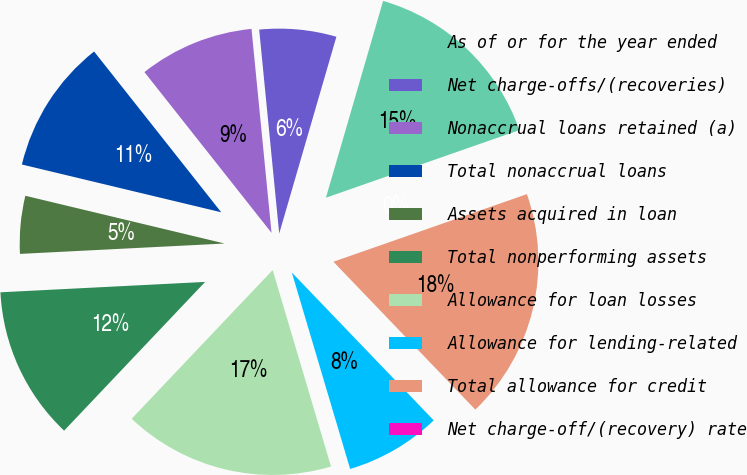Convert chart. <chart><loc_0><loc_0><loc_500><loc_500><pie_chart><fcel>As of or for the year ended<fcel>Net charge-offs/(recoveries)<fcel>Nonaccrual loans retained (a)<fcel>Total nonaccrual loans<fcel>Assets acquired in loan<fcel>Total nonperforming assets<fcel>Allowance for loan losses<fcel>Allowance for lending-related<fcel>Total allowance for credit<fcel>Net charge-off/(recovery) rate<nl><fcel>15.15%<fcel>6.06%<fcel>9.09%<fcel>10.61%<fcel>4.55%<fcel>12.12%<fcel>16.67%<fcel>7.58%<fcel>18.18%<fcel>0.0%<nl></chart> 